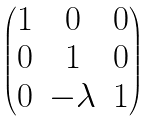<formula> <loc_0><loc_0><loc_500><loc_500>\begin{pmatrix} 1 & 0 & 0 \\ 0 & 1 & 0 \\ 0 & - \lambda & 1 \\ \end{pmatrix}</formula> 